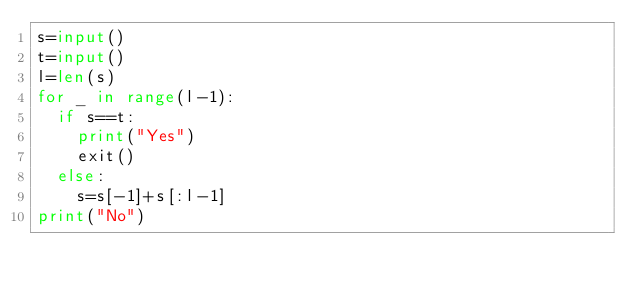<code> <loc_0><loc_0><loc_500><loc_500><_Python_>s=input()
t=input()
l=len(s)
for _ in range(l-1):
  if s==t:
    print("Yes")
    exit()
  else:
    s=s[-1]+s[:l-1]
print("No")</code> 